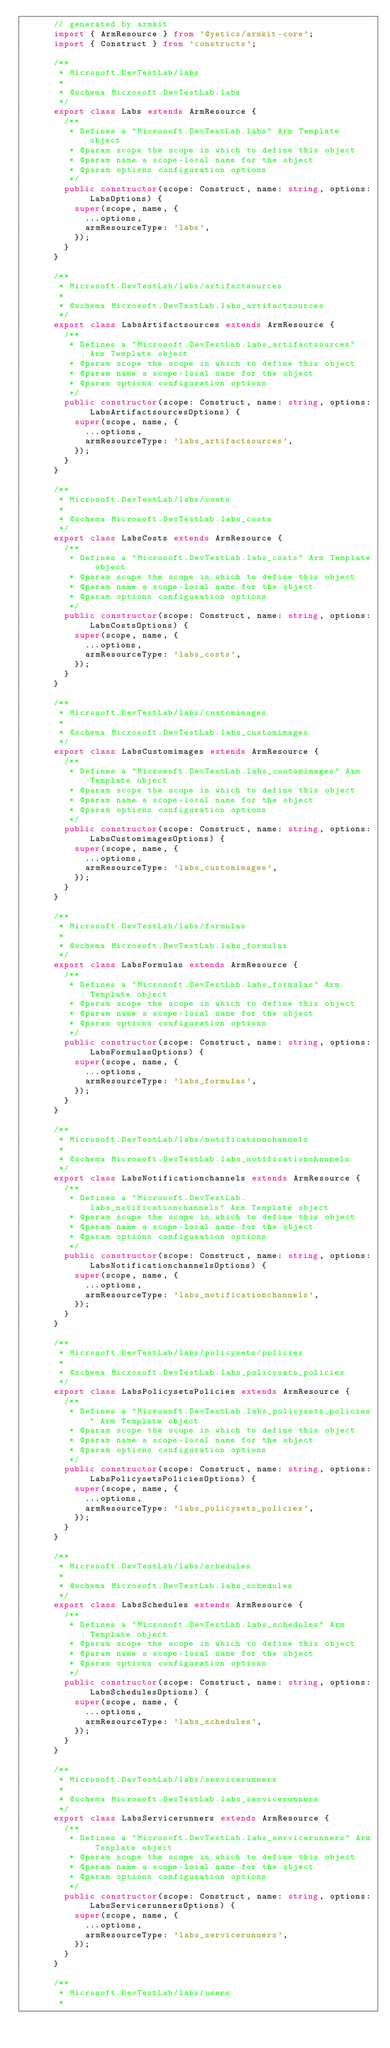Convert code to text. <code><loc_0><loc_0><loc_500><loc_500><_TypeScript_>      // generated by armkit
      import { ArmResource } from '@yetics/armkit-core';
      import { Construct } from 'constructs';

      /**
       * Microsoft.DevTestLab/labs
       *
       * @schema Microsoft.DevTestLab.labs
       */
      export class Labs extends ArmResource {
        /**
         * Defines a "Microsoft.DevTestLab.labs" Arm Template object
         * @param scope the scope in which to define this object
         * @param name a scope-local name for the object
         * @param options configuration options
         */
        public constructor(scope: Construct, name: string, options: LabsOptions) {
          super(scope, name, {
            ...options,
            armResourceType: 'labs',
          });
        }
      }

      /**
       * Microsoft.DevTestLab/labs/artifactsources
       *
       * @schema Microsoft.DevTestLab.labs_artifactsources
       */
      export class LabsArtifactsources extends ArmResource {
        /**
         * Defines a "Microsoft.DevTestLab.labs_artifactsources" Arm Template object
         * @param scope the scope in which to define this object
         * @param name a scope-local name for the object
         * @param options configuration options
         */
        public constructor(scope: Construct, name: string, options: LabsArtifactsourcesOptions) {
          super(scope, name, {
            ...options,
            armResourceType: 'labs_artifactsources',
          });
        }
      }

      /**
       * Microsoft.DevTestLab/labs/costs
       *
       * @schema Microsoft.DevTestLab.labs_costs
       */
      export class LabsCosts extends ArmResource {
        /**
         * Defines a "Microsoft.DevTestLab.labs_costs" Arm Template object
         * @param scope the scope in which to define this object
         * @param name a scope-local name for the object
         * @param options configuration options
         */
        public constructor(scope: Construct, name: string, options: LabsCostsOptions) {
          super(scope, name, {
            ...options,
            armResourceType: 'labs_costs',
          });
        }
      }

      /**
       * Microsoft.DevTestLab/labs/customimages
       *
       * @schema Microsoft.DevTestLab.labs_customimages
       */
      export class LabsCustomimages extends ArmResource {
        /**
         * Defines a "Microsoft.DevTestLab.labs_customimages" Arm Template object
         * @param scope the scope in which to define this object
         * @param name a scope-local name for the object
         * @param options configuration options
         */
        public constructor(scope: Construct, name: string, options: LabsCustomimagesOptions) {
          super(scope, name, {
            ...options,
            armResourceType: 'labs_customimages',
          });
        }
      }

      /**
       * Microsoft.DevTestLab/labs/formulas
       *
       * @schema Microsoft.DevTestLab.labs_formulas
       */
      export class LabsFormulas extends ArmResource {
        /**
         * Defines a "Microsoft.DevTestLab.labs_formulas" Arm Template object
         * @param scope the scope in which to define this object
         * @param name a scope-local name for the object
         * @param options configuration options
         */
        public constructor(scope: Construct, name: string, options: LabsFormulasOptions) {
          super(scope, name, {
            ...options,
            armResourceType: 'labs_formulas',
          });
        }
      }

      /**
       * Microsoft.DevTestLab/labs/notificationchannels
       *
       * @schema Microsoft.DevTestLab.labs_notificationchannels
       */
      export class LabsNotificationchannels extends ArmResource {
        /**
         * Defines a "Microsoft.DevTestLab.labs_notificationchannels" Arm Template object
         * @param scope the scope in which to define this object
         * @param name a scope-local name for the object
         * @param options configuration options
         */
        public constructor(scope: Construct, name: string, options: LabsNotificationchannelsOptions) {
          super(scope, name, {
            ...options,
            armResourceType: 'labs_notificationchannels',
          });
        }
      }

      /**
       * Microsoft.DevTestLab/labs/policysets/policies
       *
       * @schema Microsoft.DevTestLab.labs_policysets_policies
       */
      export class LabsPolicysetsPolicies extends ArmResource {
        /**
         * Defines a "Microsoft.DevTestLab.labs_policysets_policies" Arm Template object
         * @param scope the scope in which to define this object
         * @param name a scope-local name for the object
         * @param options configuration options
         */
        public constructor(scope: Construct, name: string, options: LabsPolicysetsPoliciesOptions) {
          super(scope, name, {
            ...options,
            armResourceType: 'labs_policysets_policies',
          });
        }
      }

      /**
       * Microsoft.DevTestLab/labs/schedules
       *
       * @schema Microsoft.DevTestLab.labs_schedules
       */
      export class LabsSchedules extends ArmResource {
        /**
         * Defines a "Microsoft.DevTestLab.labs_schedules" Arm Template object
         * @param scope the scope in which to define this object
         * @param name a scope-local name for the object
         * @param options configuration options
         */
        public constructor(scope: Construct, name: string, options: LabsSchedulesOptions) {
          super(scope, name, {
            ...options,
            armResourceType: 'labs_schedules',
          });
        }
      }

      /**
       * Microsoft.DevTestLab/labs/servicerunners
       *
       * @schema Microsoft.DevTestLab.labs_servicerunners
       */
      export class LabsServicerunners extends ArmResource {
        /**
         * Defines a "Microsoft.DevTestLab.labs_servicerunners" Arm Template object
         * @param scope the scope in which to define this object
         * @param name a scope-local name for the object
         * @param options configuration options
         */
        public constructor(scope: Construct, name: string, options: LabsServicerunnersOptions) {
          super(scope, name, {
            ...options,
            armResourceType: 'labs_servicerunners',
          });
        }
      }

      /**
       * Microsoft.DevTestLab/labs/users
       *</code> 